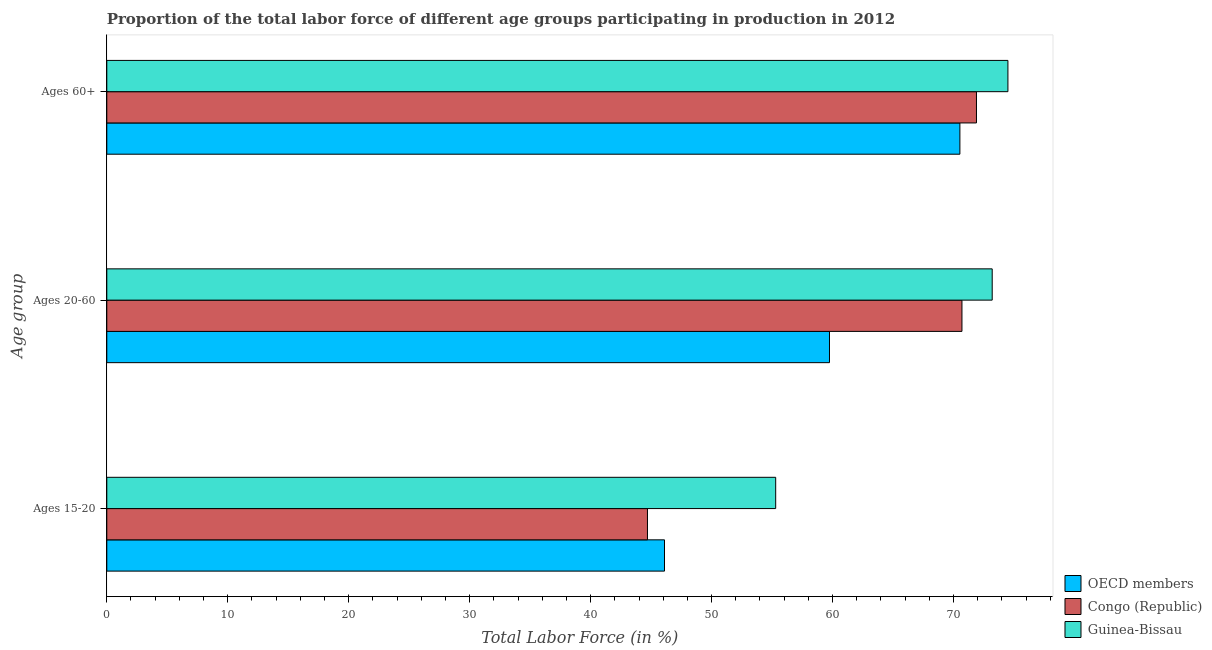How many different coloured bars are there?
Offer a very short reply. 3. How many groups of bars are there?
Provide a succinct answer. 3. What is the label of the 1st group of bars from the top?
Keep it short and to the point. Ages 60+. What is the percentage of labor force within the age group 20-60 in Congo (Republic)?
Ensure brevity in your answer.  70.7. Across all countries, what is the maximum percentage of labor force above age 60?
Your answer should be very brief. 74.5. Across all countries, what is the minimum percentage of labor force within the age group 20-60?
Keep it short and to the point. 59.75. In which country was the percentage of labor force within the age group 20-60 maximum?
Provide a short and direct response. Guinea-Bissau. In which country was the percentage of labor force above age 60 minimum?
Keep it short and to the point. OECD members. What is the total percentage of labor force above age 60 in the graph?
Offer a very short reply. 216.93. What is the difference between the percentage of labor force above age 60 in OECD members and that in Guinea-Bissau?
Give a very brief answer. -3.97. What is the difference between the percentage of labor force above age 60 in Congo (Republic) and the percentage of labor force within the age group 15-20 in OECD members?
Offer a terse response. 25.79. What is the average percentage of labor force above age 60 per country?
Your response must be concise. 72.31. What is the difference between the percentage of labor force above age 60 and percentage of labor force within the age group 20-60 in OECD members?
Give a very brief answer. 10.78. What is the ratio of the percentage of labor force within the age group 20-60 in Congo (Republic) to that in Guinea-Bissau?
Provide a short and direct response. 0.97. Is the percentage of labor force within the age group 20-60 in OECD members less than that in Congo (Republic)?
Give a very brief answer. Yes. Is the difference between the percentage of labor force above age 60 in Guinea-Bissau and Congo (Republic) greater than the difference between the percentage of labor force within the age group 15-20 in Guinea-Bissau and Congo (Republic)?
Make the answer very short. No. What is the difference between the highest and the second highest percentage of labor force above age 60?
Offer a terse response. 2.6. What is the difference between the highest and the lowest percentage of labor force above age 60?
Your answer should be very brief. 3.97. In how many countries, is the percentage of labor force within the age group 20-60 greater than the average percentage of labor force within the age group 20-60 taken over all countries?
Provide a short and direct response. 2. Is the sum of the percentage of labor force above age 60 in OECD members and Guinea-Bissau greater than the maximum percentage of labor force within the age group 20-60 across all countries?
Make the answer very short. Yes. What does the 2nd bar from the bottom in Ages 60+ represents?
Keep it short and to the point. Congo (Republic). Are all the bars in the graph horizontal?
Make the answer very short. Yes. Does the graph contain any zero values?
Give a very brief answer. No. Does the graph contain grids?
Ensure brevity in your answer.  No. Where does the legend appear in the graph?
Keep it short and to the point. Bottom right. How many legend labels are there?
Offer a terse response. 3. How are the legend labels stacked?
Give a very brief answer. Vertical. What is the title of the graph?
Provide a succinct answer. Proportion of the total labor force of different age groups participating in production in 2012. What is the label or title of the X-axis?
Your answer should be very brief. Total Labor Force (in %). What is the label or title of the Y-axis?
Your answer should be compact. Age group. What is the Total Labor Force (in %) in OECD members in Ages 15-20?
Make the answer very short. 46.11. What is the Total Labor Force (in %) of Congo (Republic) in Ages 15-20?
Give a very brief answer. 44.7. What is the Total Labor Force (in %) of Guinea-Bissau in Ages 15-20?
Give a very brief answer. 55.3. What is the Total Labor Force (in %) in OECD members in Ages 20-60?
Your answer should be very brief. 59.75. What is the Total Labor Force (in %) of Congo (Republic) in Ages 20-60?
Make the answer very short. 70.7. What is the Total Labor Force (in %) in Guinea-Bissau in Ages 20-60?
Provide a succinct answer. 73.2. What is the Total Labor Force (in %) of OECD members in Ages 60+?
Provide a short and direct response. 70.53. What is the Total Labor Force (in %) of Congo (Republic) in Ages 60+?
Ensure brevity in your answer.  71.9. What is the Total Labor Force (in %) of Guinea-Bissau in Ages 60+?
Give a very brief answer. 74.5. Across all Age group, what is the maximum Total Labor Force (in %) in OECD members?
Your answer should be compact. 70.53. Across all Age group, what is the maximum Total Labor Force (in %) of Congo (Republic)?
Offer a very short reply. 71.9. Across all Age group, what is the maximum Total Labor Force (in %) of Guinea-Bissau?
Offer a very short reply. 74.5. Across all Age group, what is the minimum Total Labor Force (in %) of OECD members?
Provide a short and direct response. 46.11. Across all Age group, what is the minimum Total Labor Force (in %) in Congo (Republic)?
Offer a very short reply. 44.7. Across all Age group, what is the minimum Total Labor Force (in %) in Guinea-Bissau?
Provide a succinct answer. 55.3. What is the total Total Labor Force (in %) of OECD members in the graph?
Your response must be concise. 176.38. What is the total Total Labor Force (in %) of Congo (Republic) in the graph?
Keep it short and to the point. 187.3. What is the total Total Labor Force (in %) of Guinea-Bissau in the graph?
Offer a terse response. 203. What is the difference between the Total Labor Force (in %) in OECD members in Ages 15-20 and that in Ages 20-60?
Your answer should be compact. -13.64. What is the difference between the Total Labor Force (in %) in Congo (Republic) in Ages 15-20 and that in Ages 20-60?
Your response must be concise. -26. What is the difference between the Total Labor Force (in %) of Guinea-Bissau in Ages 15-20 and that in Ages 20-60?
Ensure brevity in your answer.  -17.9. What is the difference between the Total Labor Force (in %) in OECD members in Ages 15-20 and that in Ages 60+?
Your answer should be compact. -24.42. What is the difference between the Total Labor Force (in %) of Congo (Republic) in Ages 15-20 and that in Ages 60+?
Give a very brief answer. -27.2. What is the difference between the Total Labor Force (in %) in Guinea-Bissau in Ages 15-20 and that in Ages 60+?
Keep it short and to the point. -19.2. What is the difference between the Total Labor Force (in %) of OECD members in Ages 20-60 and that in Ages 60+?
Provide a short and direct response. -10.78. What is the difference between the Total Labor Force (in %) in Congo (Republic) in Ages 20-60 and that in Ages 60+?
Provide a succinct answer. -1.2. What is the difference between the Total Labor Force (in %) of OECD members in Ages 15-20 and the Total Labor Force (in %) of Congo (Republic) in Ages 20-60?
Provide a succinct answer. -24.59. What is the difference between the Total Labor Force (in %) in OECD members in Ages 15-20 and the Total Labor Force (in %) in Guinea-Bissau in Ages 20-60?
Make the answer very short. -27.09. What is the difference between the Total Labor Force (in %) of Congo (Republic) in Ages 15-20 and the Total Labor Force (in %) of Guinea-Bissau in Ages 20-60?
Your answer should be compact. -28.5. What is the difference between the Total Labor Force (in %) of OECD members in Ages 15-20 and the Total Labor Force (in %) of Congo (Republic) in Ages 60+?
Make the answer very short. -25.79. What is the difference between the Total Labor Force (in %) of OECD members in Ages 15-20 and the Total Labor Force (in %) of Guinea-Bissau in Ages 60+?
Make the answer very short. -28.39. What is the difference between the Total Labor Force (in %) of Congo (Republic) in Ages 15-20 and the Total Labor Force (in %) of Guinea-Bissau in Ages 60+?
Keep it short and to the point. -29.8. What is the difference between the Total Labor Force (in %) in OECD members in Ages 20-60 and the Total Labor Force (in %) in Congo (Republic) in Ages 60+?
Offer a very short reply. -12.15. What is the difference between the Total Labor Force (in %) in OECD members in Ages 20-60 and the Total Labor Force (in %) in Guinea-Bissau in Ages 60+?
Offer a terse response. -14.75. What is the average Total Labor Force (in %) in OECD members per Age group?
Make the answer very short. 58.79. What is the average Total Labor Force (in %) of Congo (Republic) per Age group?
Your response must be concise. 62.43. What is the average Total Labor Force (in %) in Guinea-Bissau per Age group?
Provide a short and direct response. 67.67. What is the difference between the Total Labor Force (in %) in OECD members and Total Labor Force (in %) in Congo (Republic) in Ages 15-20?
Keep it short and to the point. 1.41. What is the difference between the Total Labor Force (in %) in OECD members and Total Labor Force (in %) in Guinea-Bissau in Ages 15-20?
Your answer should be very brief. -9.19. What is the difference between the Total Labor Force (in %) in OECD members and Total Labor Force (in %) in Congo (Republic) in Ages 20-60?
Offer a very short reply. -10.95. What is the difference between the Total Labor Force (in %) of OECD members and Total Labor Force (in %) of Guinea-Bissau in Ages 20-60?
Provide a short and direct response. -13.45. What is the difference between the Total Labor Force (in %) in OECD members and Total Labor Force (in %) in Congo (Republic) in Ages 60+?
Your response must be concise. -1.37. What is the difference between the Total Labor Force (in %) of OECD members and Total Labor Force (in %) of Guinea-Bissau in Ages 60+?
Give a very brief answer. -3.97. What is the ratio of the Total Labor Force (in %) of OECD members in Ages 15-20 to that in Ages 20-60?
Your response must be concise. 0.77. What is the ratio of the Total Labor Force (in %) in Congo (Republic) in Ages 15-20 to that in Ages 20-60?
Keep it short and to the point. 0.63. What is the ratio of the Total Labor Force (in %) of Guinea-Bissau in Ages 15-20 to that in Ages 20-60?
Provide a succinct answer. 0.76. What is the ratio of the Total Labor Force (in %) in OECD members in Ages 15-20 to that in Ages 60+?
Offer a terse response. 0.65. What is the ratio of the Total Labor Force (in %) in Congo (Republic) in Ages 15-20 to that in Ages 60+?
Keep it short and to the point. 0.62. What is the ratio of the Total Labor Force (in %) in Guinea-Bissau in Ages 15-20 to that in Ages 60+?
Provide a short and direct response. 0.74. What is the ratio of the Total Labor Force (in %) of OECD members in Ages 20-60 to that in Ages 60+?
Your answer should be compact. 0.85. What is the ratio of the Total Labor Force (in %) in Congo (Republic) in Ages 20-60 to that in Ages 60+?
Keep it short and to the point. 0.98. What is the ratio of the Total Labor Force (in %) in Guinea-Bissau in Ages 20-60 to that in Ages 60+?
Offer a terse response. 0.98. What is the difference between the highest and the second highest Total Labor Force (in %) in OECD members?
Offer a very short reply. 10.78. What is the difference between the highest and the lowest Total Labor Force (in %) of OECD members?
Keep it short and to the point. 24.42. What is the difference between the highest and the lowest Total Labor Force (in %) of Congo (Republic)?
Your answer should be compact. 27.2. 